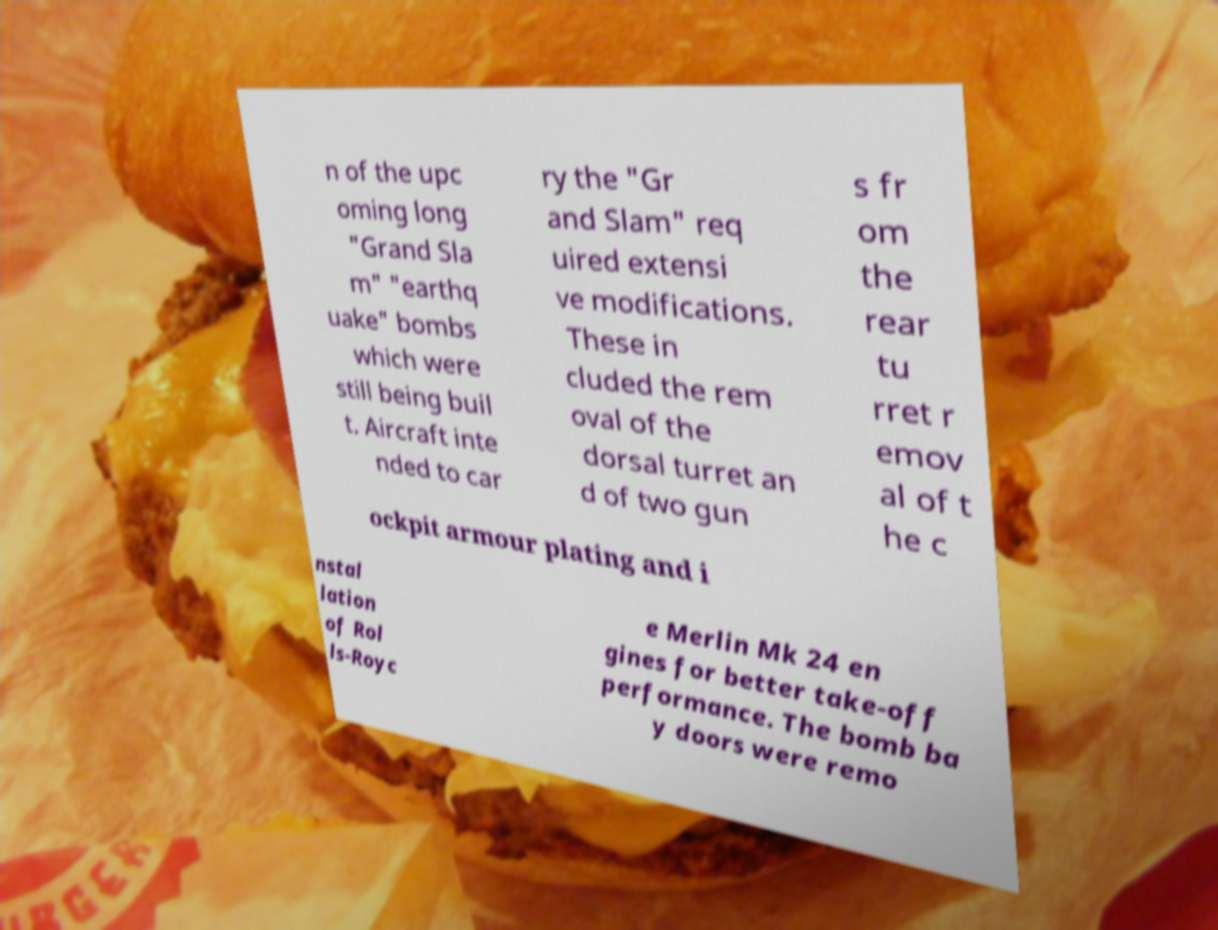Could you assist in decoding the text presented in this image and type it out clearly? n of the upc oming long "Grand Sla m" "earthq uake" bombs which were still being buil t. Aircraft inte nded to car ry the "Gr and Slam" req uired extensi ve modifications. These in cluded the rem oval of the dorsal turret an d of two gun s fr om the rear tu rret r emov al of t he c ockpit armour plating and i nstal lation of Rol ls-Royc e Merlin Mk 24 en gines for better take-off performance. The bomb ba y doors were remo 